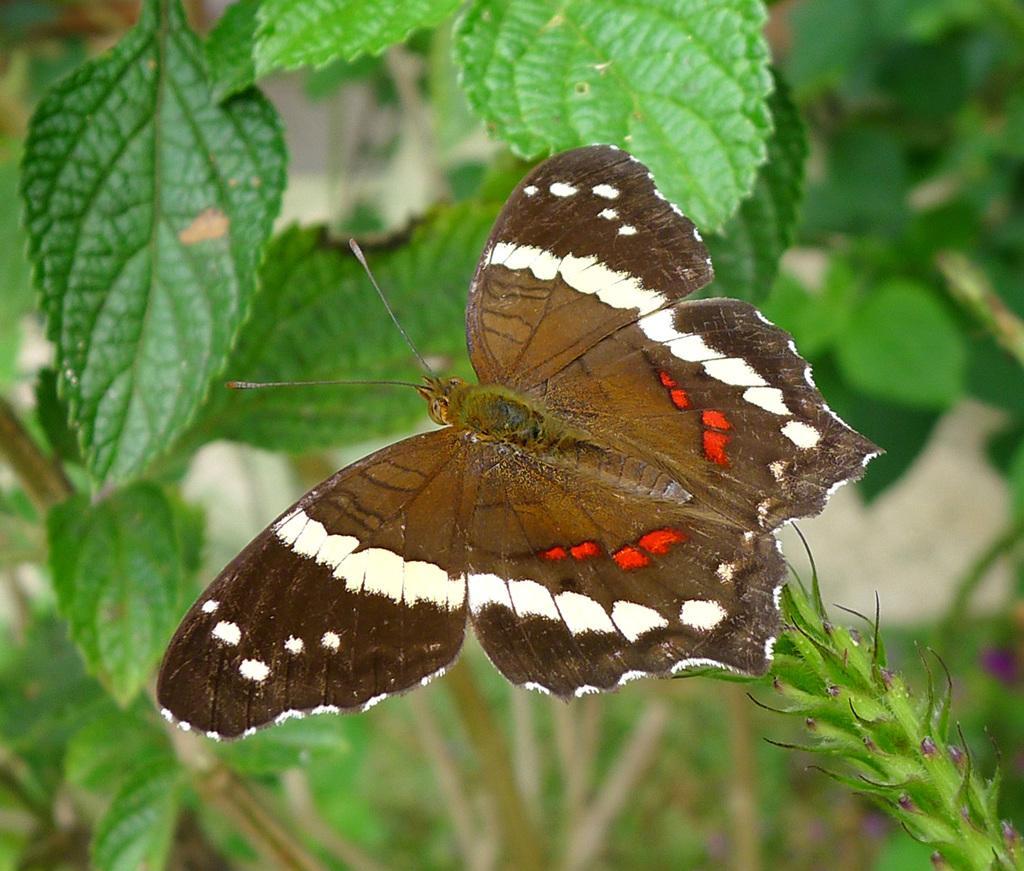Please provide a concise description of this image. In this picture we can see a butterfly, plants and in the background it is blurry. 